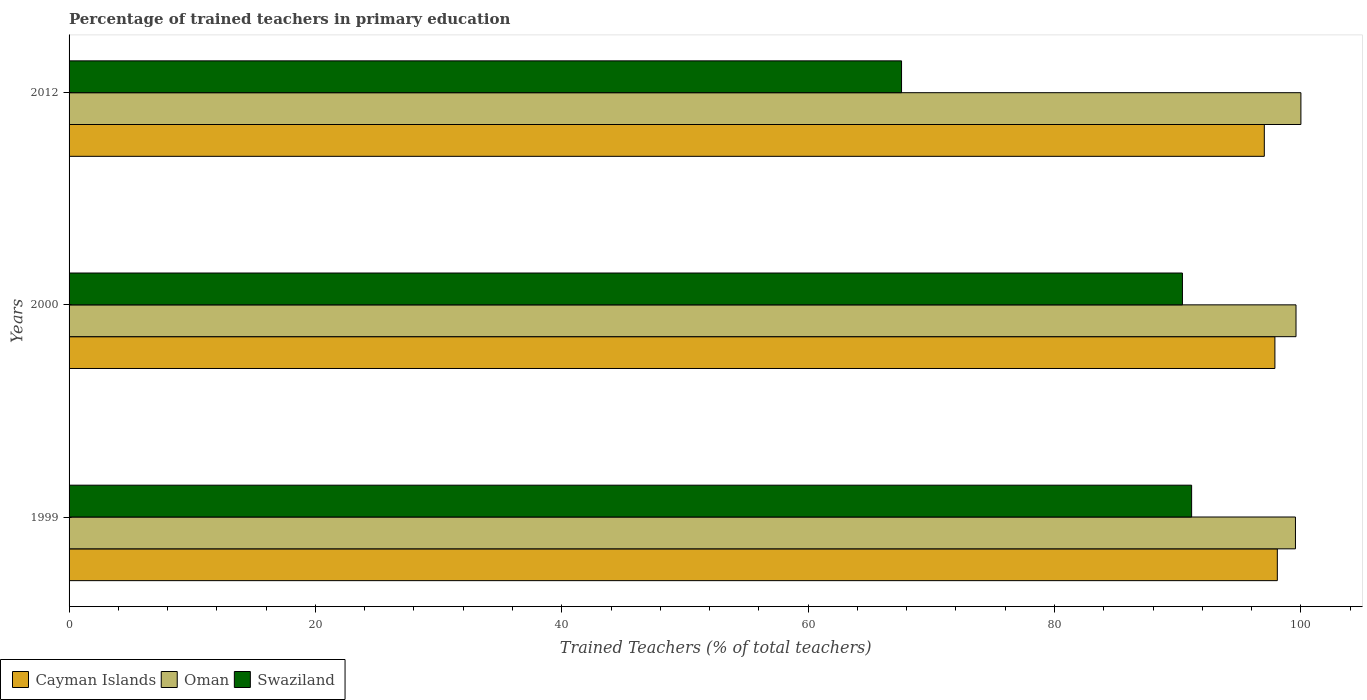How many groups of bars are there?
Your answer should be compact. 3. Are the number of bars on each tick of the Y-axis equal?
Keep it short and to the point. Yes. What is the label of the 3rd group of bars from the top?
Your response must be concise. 1999. In how many cases, is the number of bars for a given year not equal to the number of legend labels?
Offer a very short reply. 0. What is the percentage of trained teachers in Oman in 2012?
Your response must be concise. 100. Across all years, what is the maximum percentage of trained teachers in Cayman Islands?
Keep it short and to the point. 98.09. Across all years, what is the minimum percentage of trained teachers in Swaziland?
Offer a very short reply. 67.58. In which year was the percentage of trained teachers in Cayman Islands maximum?
Give a very brief answer. 1999. In which year was the percentage of trained teachers in Swaziland minimum?
Offer a terse response. 2012. What is the total percentage of trained teachers in Swaziland in the graph?
Your answer should be compact. 249.09. What is the difference between the percentage of trained teachers in Oman in 1999 and that in 2012?
Your response must be concise. -0.44. What is the difference between the percentage of trained teachers in Oman in 2000 and the percentage of trained teachers in Swaziland in 2012?
Offer a very short reply. 32.02. What is the average percentage of trained teachers in Oman per year?
Keep it short and to the point. 99.72. In the year 2000, what is the difference between the percentage of trained teachers in Oman and percentage of trained teachers in Cayman Islands?
Offer a terse response. 1.71. What is the ratio of the percentage of trained teachers in Cayman Islands in 2000 to that in 2012?
Provide a short and direct response. 1.01. Is the percentage of trained teachers in Oman in 1999 less than that in 2012?
Ensure brevity in your answer.  Yes. What is the difference between the highest and the second highest percentage of trained teachers in Cayman Islands?
Provide a succinct answer. 0.2. What is the difference between the highest and the lowest percentage of trained teachers in Oman?
Your answer should be compact. 0.44. In how many years, is the percentage of trained teachers in Swaziland greater than the average percentage of trained teachers in Swaziland taken over all years?
Give a very brief answer. 2. Is the sum of the percentage of trained teachers in Oman in 1999 and 2000 greater than the maximum percentage of trained teachers in Swaziland across all years?
Your response must be concise. Yes. What does the 2nd bar from the top in 2000 represents?
Give a very brief answer. Oman. What does the 3rd bar from the bottom in 2000 represents?
Your answer should be compact. Swaziland. Is it the case that in every year, the sum of the percentage of trained teachers in Swaziland and percentage of trained teachers in Oman is greater than the percentage of trained teachers in Cayman Islands?
Keep it short and to the point. Yes. How many bars are there?
Offer a terse response. 9. Are the values on the major ticks of X-axis written in scientific E-notation?
Your answer should be very brief. No. Does the graph contain any zero values?
Keep it short and to the point. No. Where does the legend appear in the graph?
Give a very brief answer. Bottom left. How many legend labels are there?
Your response must be concise. 3. What is the title of the graph?
Keep it short and to the point. Percentage of trained teachers in primary education. Does "Kenya" appear as one of the legend labels in the graph?
Keep it short and to the point. No. What is the label or title of the X-axis?
Ensure brevity in your answer.  Trained Teachers (% of total teachers). What is the Trained Teachers (% of total teachers) of Cayman Islands in 1999?
Your answer should be compact. 98.09. What is the Trained Teachers (% of total teachers) of Oman in 1999?
Offer a very short reply. 99.56. What is the Trained Teachers (% of total teachers) in Swaziland in 1999?
Give a very brief answer. 91.13. What is the Trained Teachers (% of total teachers) of Cayman Islands in 2000?
Your answer should be compact. 97.89. What is the Trained Teachers (% of total teachers) in Oman in 2000?
Offer a very short reply. 99.6. What is the Trained Teachers (% of total teachers) in Swaziland in 2000?
Give a very brief answer. 90.38. What is the Trained Teachers (% of total teachers) in Cayman Islands in 2012?
Your response must be concise. 97.03. What is the Trained Teachers (% of total teachers) of Oman in 2012?
Provide a short and direct response. 100. What is the Trained Teachers (% of total teachers) of Swaziland in 2012?
Your response must be concise. 67.58. Across all years, what is the maximum Trained Teachers (% of total teachers) in Cayman Islands?
Provide a succinct answer. 98.09. Across all years, what is the maximum Trained Teachers (% of total teachers) in Swaziland?
Provide a short and direct response. 91.13. Across all years, what is the minimum Trained Teachers (% of total teachers) in Cayman Islands?
Keep it short and to the point. 97.03. Across all years, what is the minimum Trained Teachers (% of total teachers) in Oman?
Your response must be concise. 99.56. Across all years, what is the minimum Trained Teachers (% of total teachers) in Swaziland?
Keep it short and to the point. 67.58. What is the total Trained Teachers (% of total teachers) of Cayman Islands in the graph?
Ensure brevity in your answer.  293.01. What is the total Trained Teachers (% of total teachers) in Oman in the graph?
Give a very brief answer. 299.16. What is the total Trained Teachers (% of total teachers) of Swaziland in the graph?
Your response must be concise. 249.09. What is the difference between the Trained Teachers (% of total teachers) in Cayman Islands in 1999 and that in 2000?
Keep it short and to the point. 0.2. What is the difference between the Trained Teachers (% of total teachers) of Oman in 1999 and that in 2000?
Provide a succinct answer. -0.05. What is the difference between the Trained Teachers (% of total teachers) of Swaziland in 1999 and that in 2000?
Offer a very short reply. 0.75. What is the difference between the Trained Teachers (% of total teachers) in Cayman Islands in 1999 and that in 2012?
Your answer should be very brief. 1.06. What is the difference between the Trained Teachers (% of total teachers) in Oman in 1999 and that in 2012?
Your answer should be very brief. -0.44. What is the difference between the Trained Teachers (% of total teachers) of Swaziland in 1999 and that in 2012?
Your answer should be compact. 23.55. What is the difference between the Trained Teachers (% of total teachers) in Cayman Islands in 2000 and that in 2012?
Provide a short and direct response. 0.86. What is the difference between the Trained Teachers (% of total teachers) in Oman in 2000 and that in 2012?
Your answer should be very brief. -0.4. What is the difference between the Trained Teachers (% of total teachers) in Swaziland in 2000 and that in 2012?
Your answer should be compact. 22.8. What is the difference between the Trained Teachers (% of total teachers) of Cayman Islands in 1999 and the Trained Teachers (% of total teachers) of Oman in 2000?
Make the answer very short. -1.52. What is the difference between the Trained Teachers (% of total teachers) in Cayman Islands in 1999 and the Trained Teachers (% of total teachers) in Swaziland in 2000?
Keep it short and to the point. 7.7. What is the difference between the Trained Teachers (% of total teachers) in Oman in 1999 and the Trained Teachers (% of total teachers) in Swaziland in 2000?
Your answer should be compact. 9.17. What is the difference between the Trained Teachers (% of total teachers) of Cayman Islands in 1999 and the Trained Teachers (% of total teachers) of Oman in 2012?
Offer a very short reply. -1.91. What is the difference between the Trained Teachers (% of total teachers) in Cayman Islands in 1999 and the Trained Teachers (% of total teachers) in Swaziland in 2012?
Offer a very short reply. 30.51. What is the difference between the Trained Teachers (% of total teachers) of Oman in 1999 and the Trained Teachers (% of total teachers) of Swaziland in 2012?
Make the answer very short. 31.98. What is the difference between the Trained Teachers (% of total teachers) in Cayman Islands in 2000 and the Trained Teachers (% of total teachers) in Oman in 2012?
Your answer should be compact. -2.11. What is the difference between the Trained Teachers (% of total teachers) of Cayman Islands in 2000 and the Trained Teachers (% of total teachers) of Swaziland in 2012?
Make the answer very short. 30.31. What is the difference between the Trained Teachers (% of total teachers) in Oman in 2000 and the Trained Teachers (% of total teachers) in Swaziland in 2012?
Ensure brevity in your answer.  32.02. What is the average Trained Teachers (% of total teachers) of Cayman Islands per year?
Your answer should be very brief. 97.67. What is the average Trained Teachers (% of total teachers) in Oman per year?
Your response must be concise. 99.72. What is the average Trained Teachers (% of total teachers) of Swaziland per year?
Offer a terse response. 83.03. In the year 1999, what is the difference between the Trained Teachers (% of total teachers) of Cayman Islands and Trained Teachers (% of total teachers) of Oman?
Your answer should be compact. -1.47. In the year 1999, what is the difference between the Trained Teachers (% of total teachers) of Cayman Islands and Trained Teachers (% of total teachers) of Swaziland?
Offer a very short reply. 6.96. In the year 1999, what is the difference between the Trained Teachers (% of total teachers) of Oman and Trained Teachers (% of total teachers) of Swaziland?
Keep it short and to the point. 8.43. In the year 2000, what is the difference between the Trained Teachers (% of total teachers) in Cayman Islands and Trained Teachers (% of total teachers) in Oman?
Offer a terse response. -1.71. In the year 2000, what is the difference between the Trained Teachers (% of total teachers) in Cayman Islands and Trained Teachers (% of total teachers) in Swaziland?
Keep it short and to the point. 7.51. In the year 2000, what is the difference between the Trained Teachers (% of total teachers) in Oman and Trained Teachers (% of total teachers) in Swaziland?
Your answer should be compact. 9.22. In the year 2012, what is the difference between the Trained Teachers (% of total teachers) in Cayman Islands and Trained Teachers (% of total teachers) in Oman?
Your answer should be compact. -2.97. In the year 2012, what is the difference between the Trained Teachers (% of total teachers) in Cayman Islands and Trained Teachers (% of total teachers) in Swaziland?
Provide a short and direct response. 29.45. In the year 2012, what is the difference between the Trained Teachers (% of total teachers) in Oman and Trained Teachers (% of total teachers) in Swaziland?
Your answer should be very brief. 32.42. What is the ratio of the Trained Teachers (% of total teachers) in Swaziland in 1999 to that in 2000?
Your answer should be very brief. 1.01. What is the ratio of the Trained Teachers (% of total teachers) of Cayman Islands in 1999 to that in 2012?
Keep it short and to the point. 1.01. What is the ratio of the Trained Teachers (% of total teachers) of Swaziland in 1999 to that in 2012?
Make the answer very short. 1.35. What is the ratio of the Trained Teachers (% of total teachers) in Cayman Islands in 2000 to that in 2012?
Your response must be concise. 1.01. What is the ratio of the Trained Teachers (% of total teachers) of Swaziland in 2000 to that in 2012?
Your answer should be very brief. 1.34. What is the difference between the highest and the second highest Trained Teachers (% of total teachers) in Cayman Islands?
Your answer should be compact. 0.2. What is the difference between the highest and the second highest Trained Teachers (% of total teachers) of Oman?
Your response must be concise. 0.4. What is the difference between the highest and the second highest Trained Teachers (% of total teachers) in Swaziland?
Keep it short and to the point. 0.75. What is the difference between the highest and the lowest Trained Teachers (% of total teachers) in Cayman Islands?
Your answer should be compact. 1.06. What is the difference between the highest and the lowest Trained Teachers (% of total teachers) of Oman?
Offer a very short reply. 0.44. What is the difference between the highest and the lowest Trained Teachers (% of total teachers) of Swaziland?
Offer a very short reply. 23.55. 